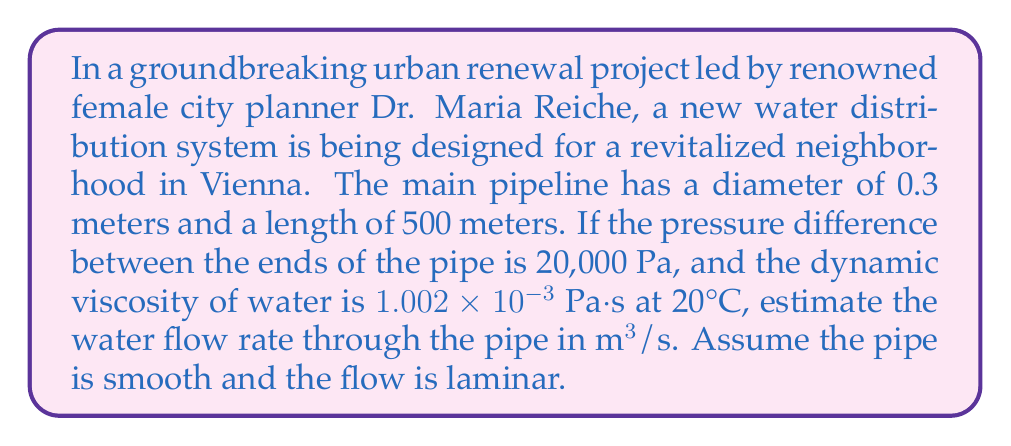Provide a solution to this math problem. To solve this problem, we'll use the Hagen-Poiseuille equation, which describes laminar flow through a pipe:

$$Q = \frac{\pi R^4 \Delta P}{8 \mu L}$$

Where:
$Q$ = volumetric flow rate (m³/s)
$R$ = radius of the pipe (m)
$\Delta P$ = pressure difference (Pa)
$\mu$ = dynamic viscosity of the fluid (Pa·s)
$L$ = length of the pipe (m)

Let's plug in the known values:

1. Calculate the radius:
   $R = \frac{diameter}{2} = \frac{0.3\text{ m}}{2} = 0.15\text{ m}$

2. Use the given values:
   $\Delta P = 20,000\text{ Pa}$
   $\mu = 1.002 \times 10^{-3}\text{ Pa·s}$
   $L = 500\text{ m}$

3. Substitute these values into the Hagen-Poiseuille equation:

   $$Q = \frac{\pi (0.15\text{ m})^4 (20,000\text{ Pa})}{8 (1.002 \times 10^{-3}\text{ Pa·s}) (500\text{ m})}$$

4. Calculate:
   $$Q = \frac{3.14159 \times (0.15)^4 \times 20,000}{8 \times 1.002 \times 10^{-3} \times 500}$$
   $$Q = \frac{0.079397}{0.004008} = 19.81\text{ m³/s}$$

Therefore, the estimated water flow rate through the pipe is approximately 19.81 m³/s.

Note: In reality, this flow rate would likely result in turbulent flow, which would require a different equation. The Hagen-Poiseuille equation is used here as requested for laminar flow.
Answer: The estimated water flow rate through the pipe is 19.81 m³/s. 